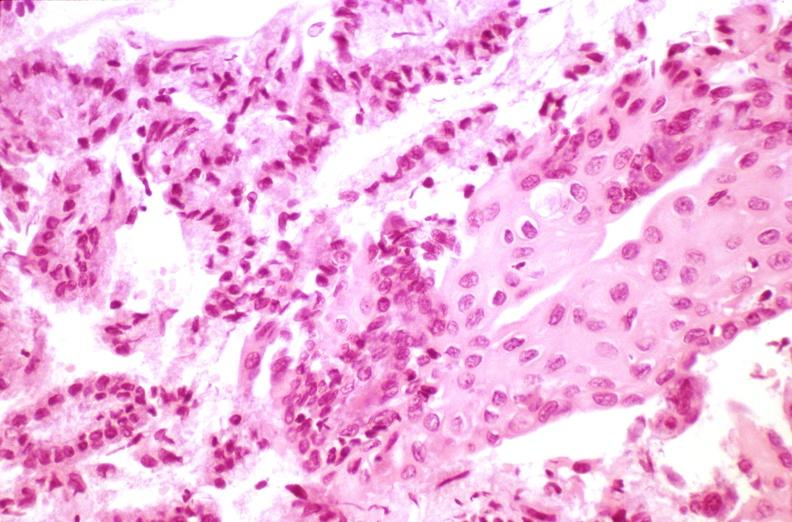what does this image show?
Answer the question using a single word or phrase. Cervix 